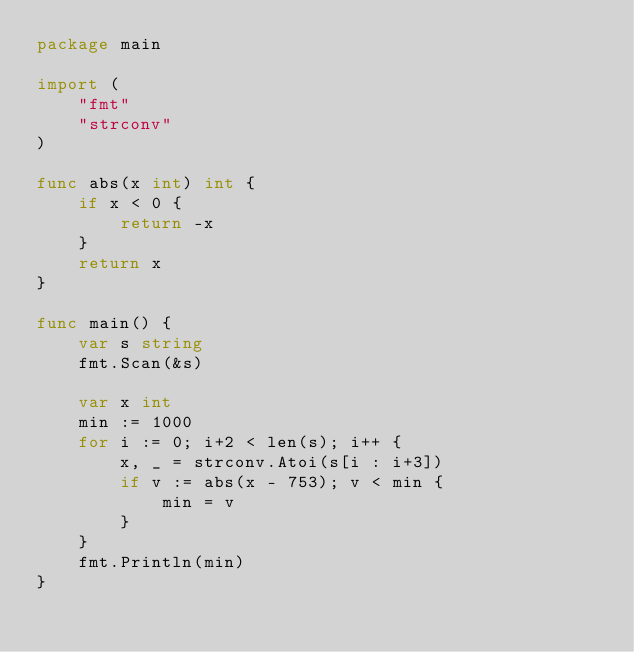Convert code to text. <code><loc_0><loc_0><loc_500><loc_500><_Go_>package main

import (
	"fmt"
	"strconv"
)

func abs(x int) int {
	if x < 0 {
		return -x
	}
	return x
}

func main() {
	var s string
	fmt.Scan(&s)

	var x int
	min := 1000
	for i := 0; i+2 < len(s); i++ {
		x, _ = strconv.Atoi(s[i : i+3])
		if v := abs(x - 753); v < min {
			min = v
		}
	}
	fmt.Println(min)
}
</code> 